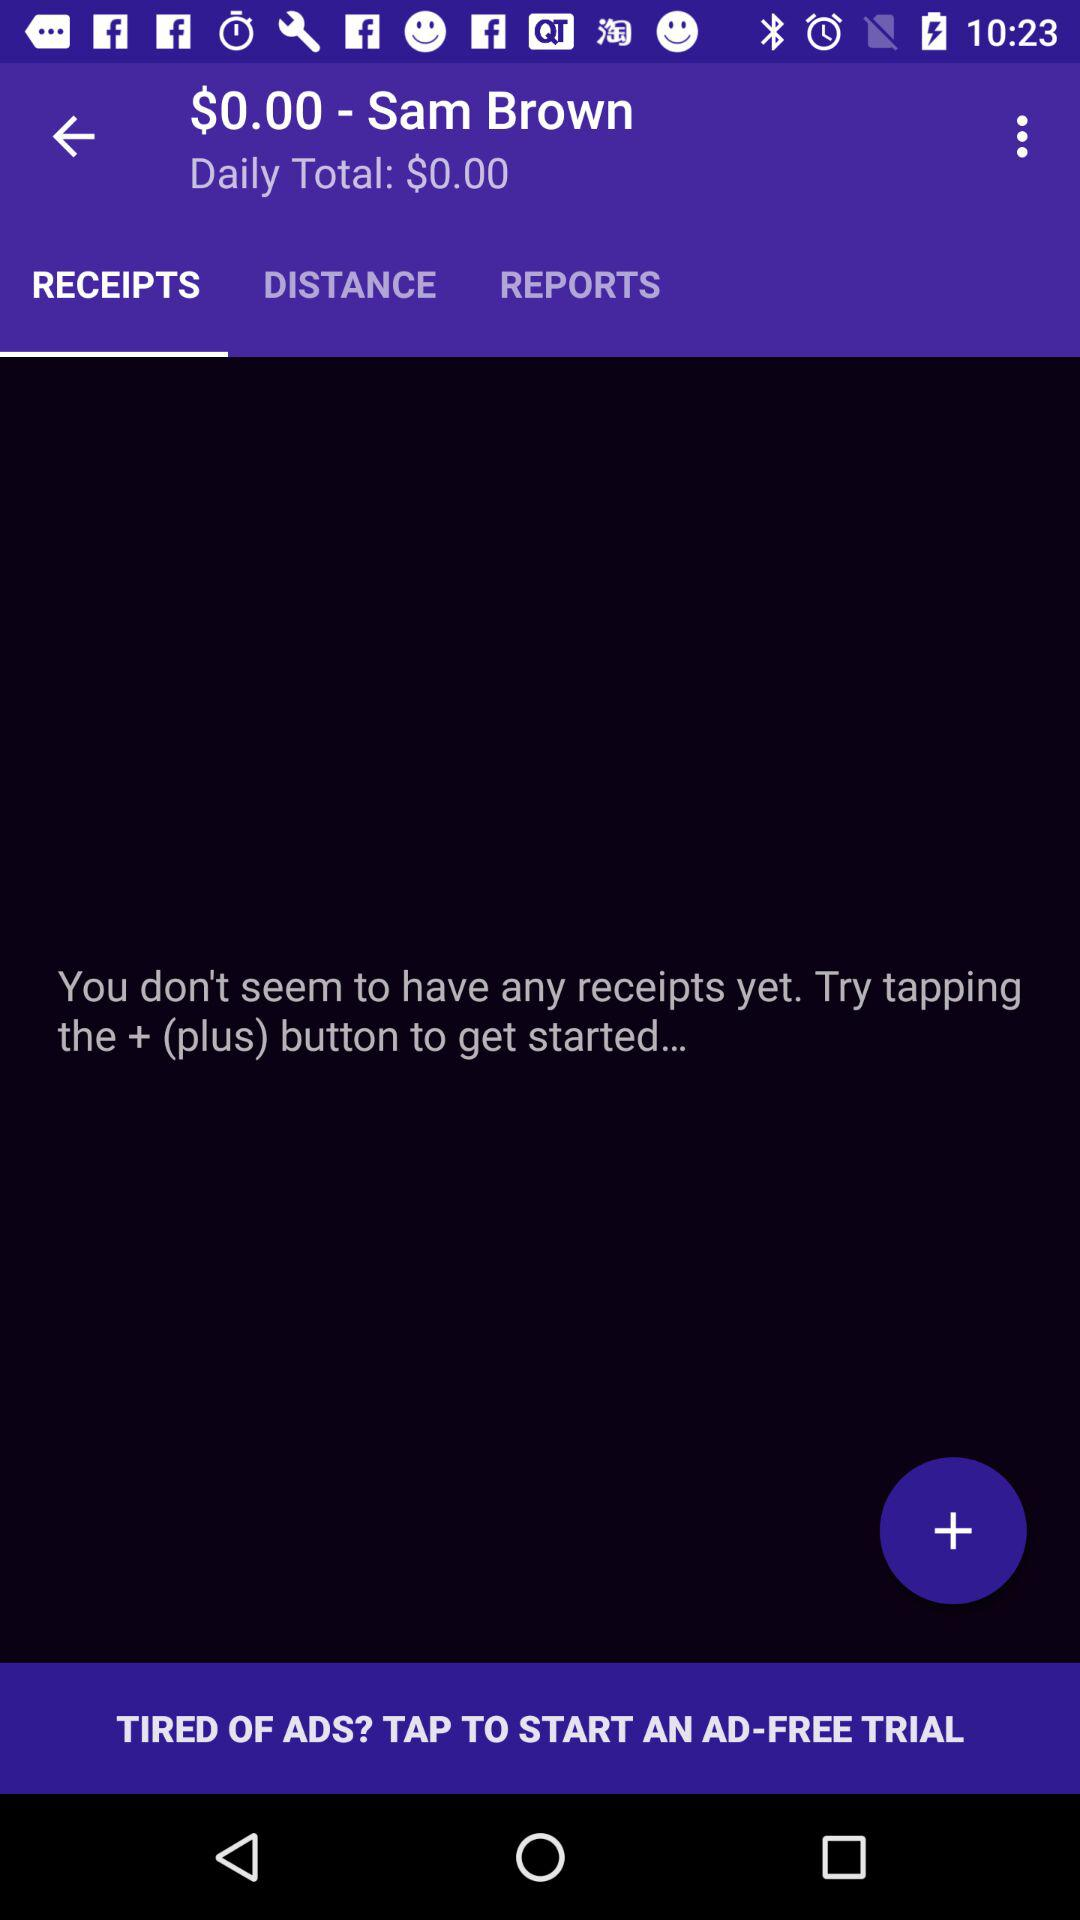What is the daily total? The daily total is $0. 